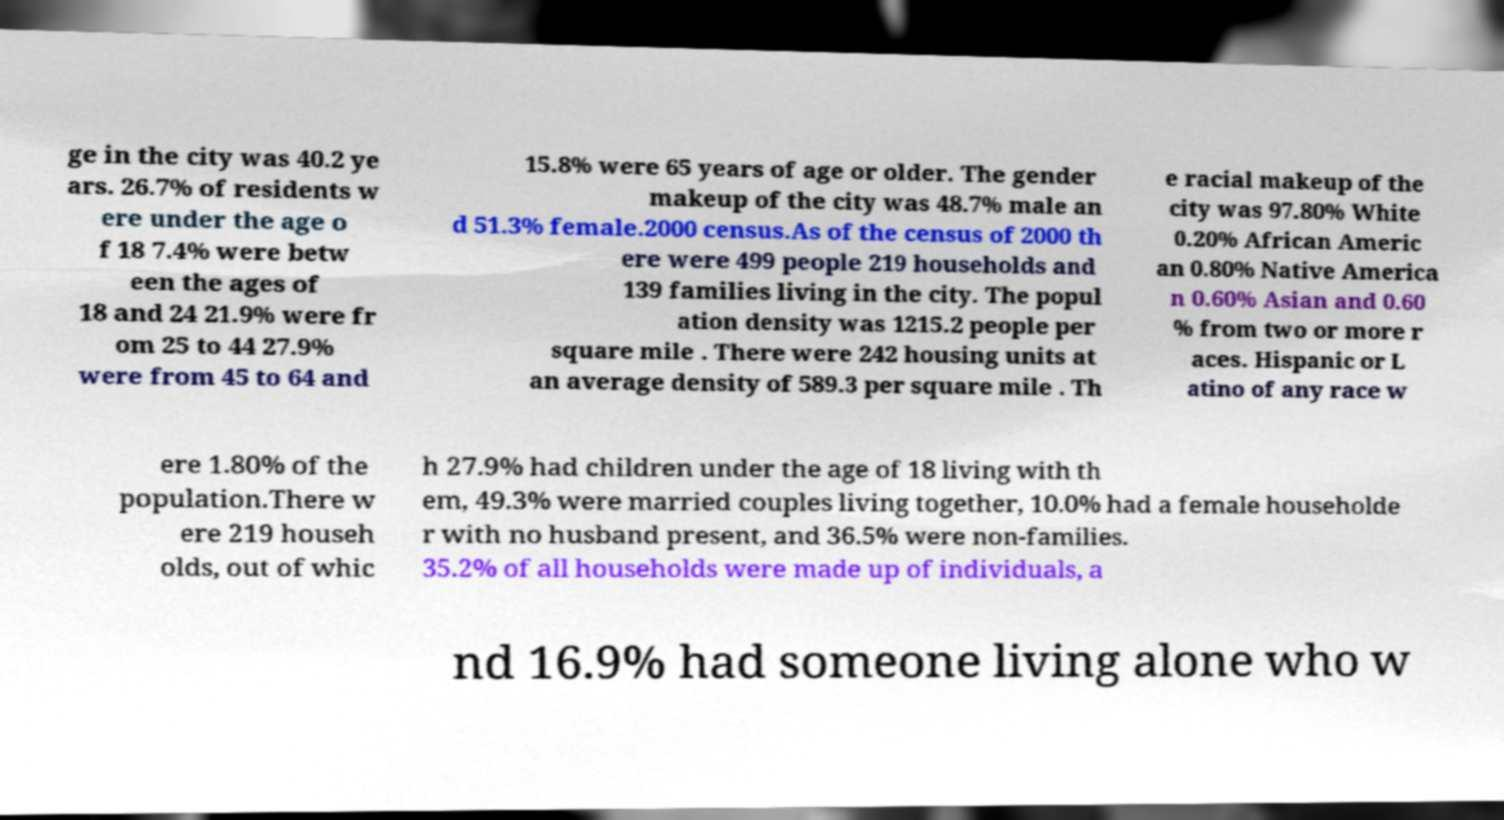Could you assist in decoding the text presented in this image and type it out clearly? ge in the city was 40.2 ye ars. 26.7% of residents w ere under the age o f 18 7.4% were betw een the ages of 18 and 24 21.9% were fr om 25 to 44 27.9% were from 45 to 64 and 15.8% were 65 years of age or older. The gender makeup of the city was 48.7% male an d 51.3% female.2000 census.As of the census of 2000 th ere were 499 people 219 households and 139 families living in the city. The popul ation density was 1215.2 people per square mile . There were 242 housing units at an average density of 589.3 per square mile . Th e racial makeup of the city was 97.80% White 0.20% African Americ an 0.80% Native America n 0.60% Asian and 0.60 % from two or more r aces. Hispanic or L atino of any race w ere 1.80% of the population.There w ere 219 househ olds, out of whic h 27.9% had children under the age of 18 living with th em, 49.3% were married couples living together, 10.0% had a female householde r with no husband present, and 36.5% were non-families. 35.2% of all households were made up of individuals, a nd 16.9% had someone living alone who w 